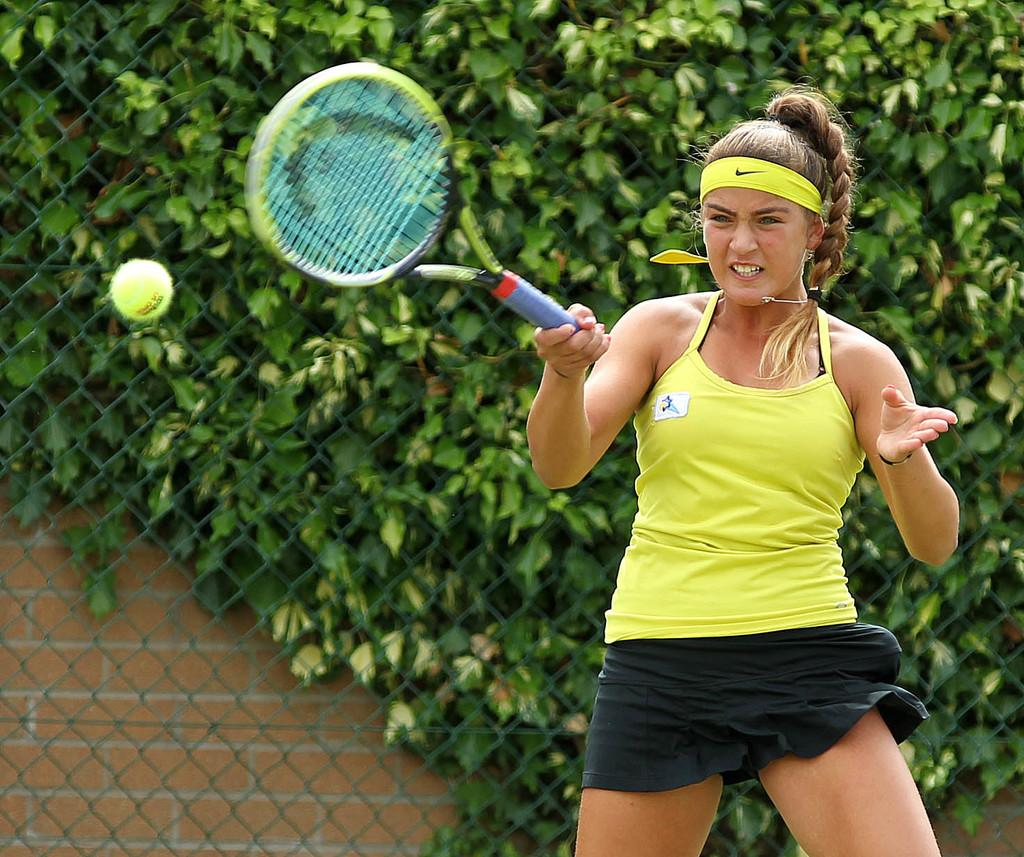What object is the woman holding in the image? The woman is holding a tennis racket. What is the purpose of the object in front of the woman? There is a tennis ball in front of the woman, which is used in the game of tennis. What can be seen in the background of the image? There are trees in the background of the image. What type of impulse can be seen affecting the ducks in the image? There are no ducks present in the image, so it is not possible to determine if any impulse is affecting them. 